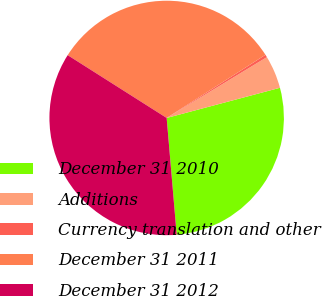<chart> <loc_0><loc_0><loc_500><loc_500><pie_chart><fcel>December 31 2010<fcel>Additions<fcel>Currency translation and other<fcel>December 31 2011<fcel>December 31 2012<nl><fcel>27.78%<fcel>4.54%<fcel>0.37%<fcel>31.95%<fcel>35.36%<nl></chart> 